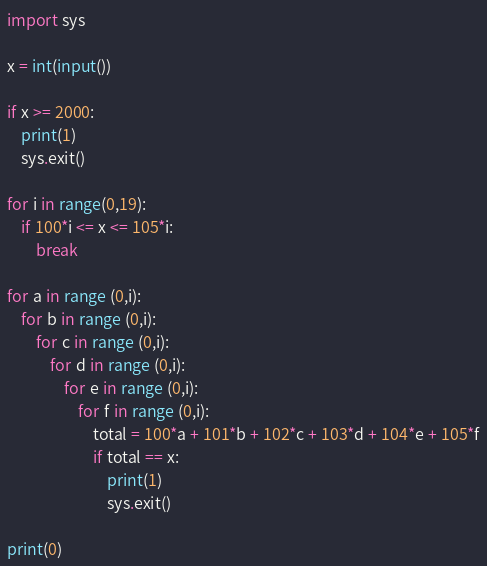<code> <loc_0><loc_0><loc_500><loc_500><_Python_>import sys

x = int(input())

if x >= 2000:
    print(1)
    sys.exit()

for i in range(0,19):
    if 100*i <= x <= 105*i:
        break

for a in range (0,i):
    for b in range (0,i):
        for c in range (0,i):
            for d in range (0,i):
                for e in range (0,i):
                    for f in range (0,i):
                        total = 100*a + 101*b + 102*c + 103*d + 104*e + 105*f
                        if total == x:
                            print(1)
                            sys.exit()

print(0)</code> 